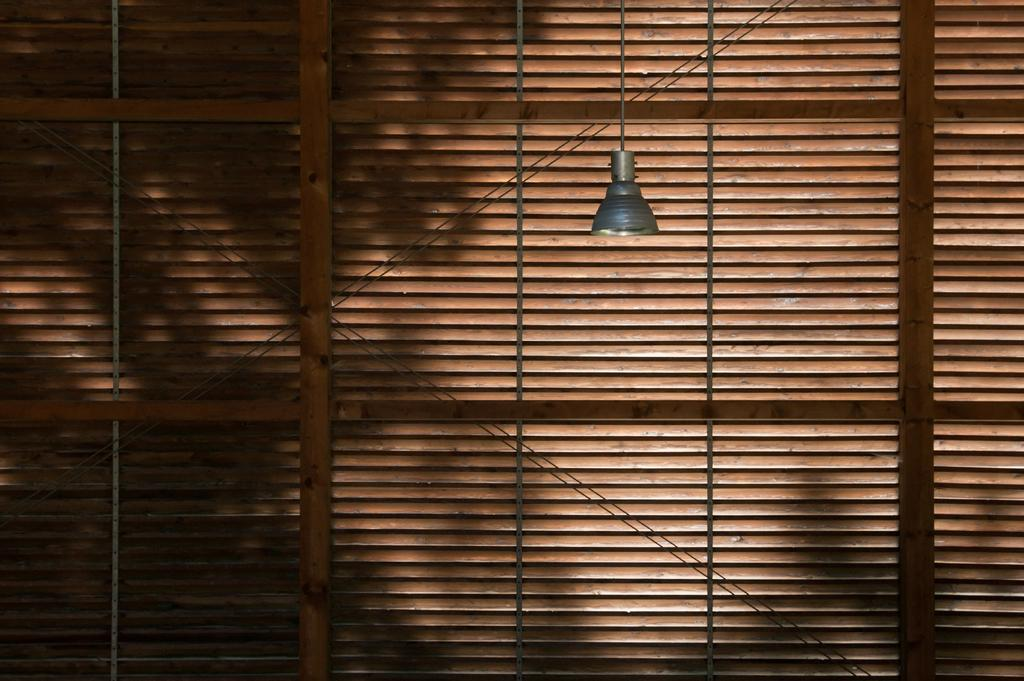What is present in the image that provides illumination? There is a light in the image. What can be seen in the background of the image? There are window blinds visible in the background of the image. What type of watch is the person wearing in the image? There is no person or watch present in the image; it only features a light and window blinds. How does the wrench help to increase the brightness of the light in the image? There is no wrench or indication of brightness adjustment in the image; it only features a light and window blinds. 